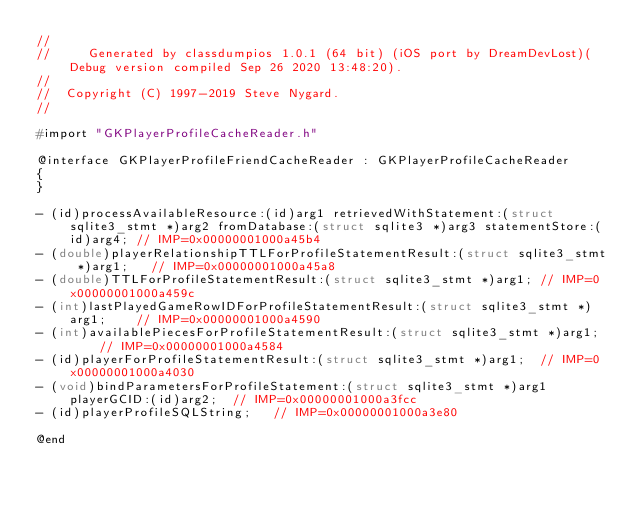Convert code to text. <code><loc_0><loc_0><loc_500><loc_500><_C_>//
//     Generated by classdumpios 1.0.1 (64 bit) (iOS port by DreamDevLost)(Debug version compiled Sep 26 2020 13:48:20).
//
//  Copyright (C) 1997-2019 Steve Nygard.
//

#import "GKPlayerProfileCacheReader.h"

@interface GKPlayerProfileFriendCacheReader : GKPlayerProfileCacheReader
{
}

- (id)processAvailableResource:(id)arg1 retrievedWithStatement:(struct sqlite3_stmt *)arg2 fromDatabase:(struct sqlite3 *)arg3 statementStore:(id)arg4;	// IMP=0x00000001000a45b4
- (double)playerRelationshipTTLForProfileStatementResult:(struct sqlite3_stmt *)arg1;	// IMP=0x00000001000a45a8
- (double)TTLForProfileStatementResult:(struct sqlite3_stmt *)arg1;	// IMP=0x00000001000a459c
- (int)lastPlayedGameRowIDForProfileStatementResult:(struct sqlite3_stmt *)arg1;	// IMP=0x00000001000a4590
- (int)availablePiecesForProfileStatementResult:(struct sqlite3_stmt *)arg1;	// IMP=0x00000001000a4584
- (id)playerForProfileStatementResult:(struct sqlite3_stmt *)arg1;	// IMP=0x00000001000a4030
- (void)bindParametersForProfileStatement:(struct sqlite3_stmt *)arg1 playerGCID:(id)arg2;	// IMP=0x00000001000a3fcc
- (id)playerProfileSQLString;	// IMP=0x00000001000a3e80

@end

</code> 